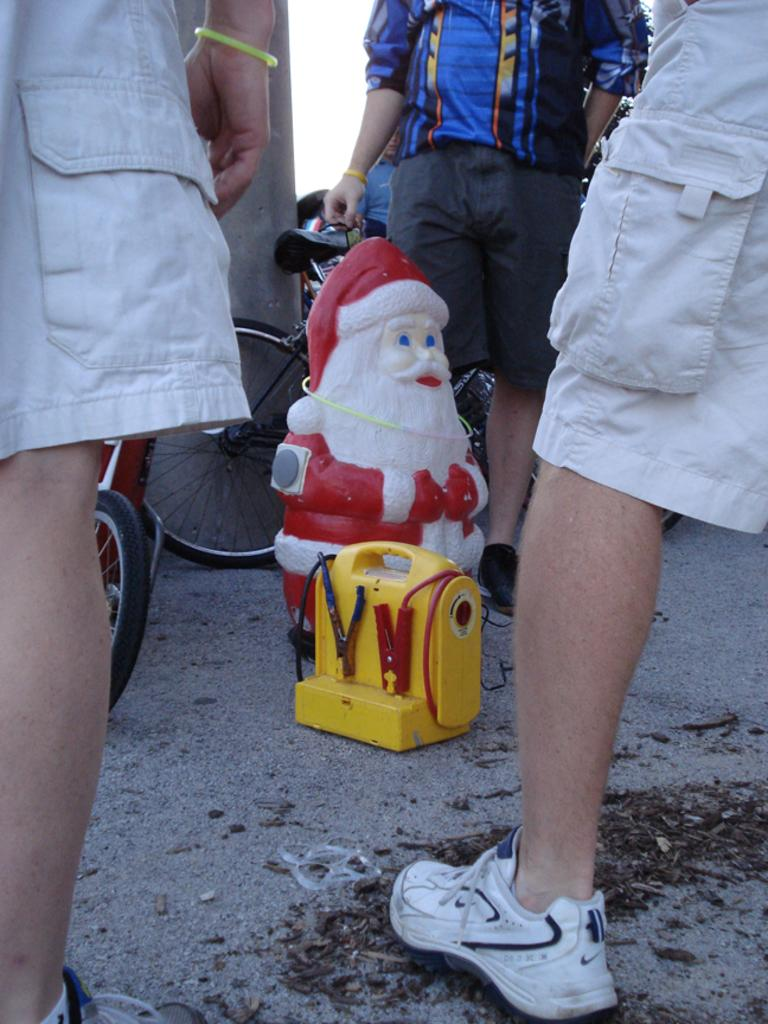What is located in the center of the image? There are toys placed on the ground in the center of the image. Who or what is beside the toys? There are people standing beside the toys. What can be seen in the background of the image? There is a wall visible in the image, and the sky is also visible. How many oranges are hanging from the wall in the image? There are no oranges present in the image; the wall is visible, but no oranges are hanging from it. 